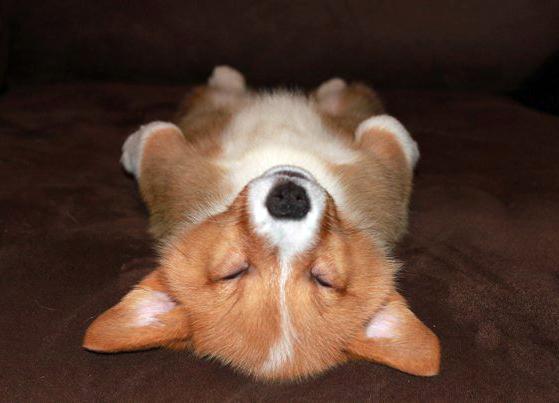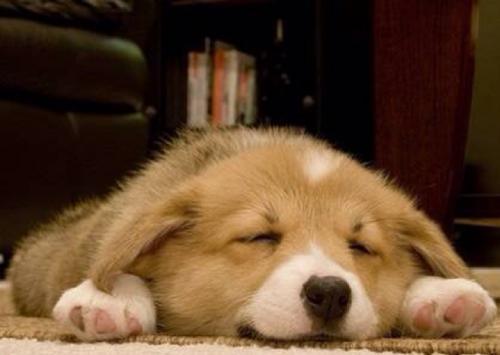The first image is the image on the left, the second image is the image on the right. For the images shown, is this caption "One dog is sleeping with a stuffed animal." true? Answer yes or no. No. The first image is the image on the left, the second image is the image on the right. For the images displayed, is the sentence "A dog is sleeping beside a stuffed toy." factually correct? Answer yes or no. No. 